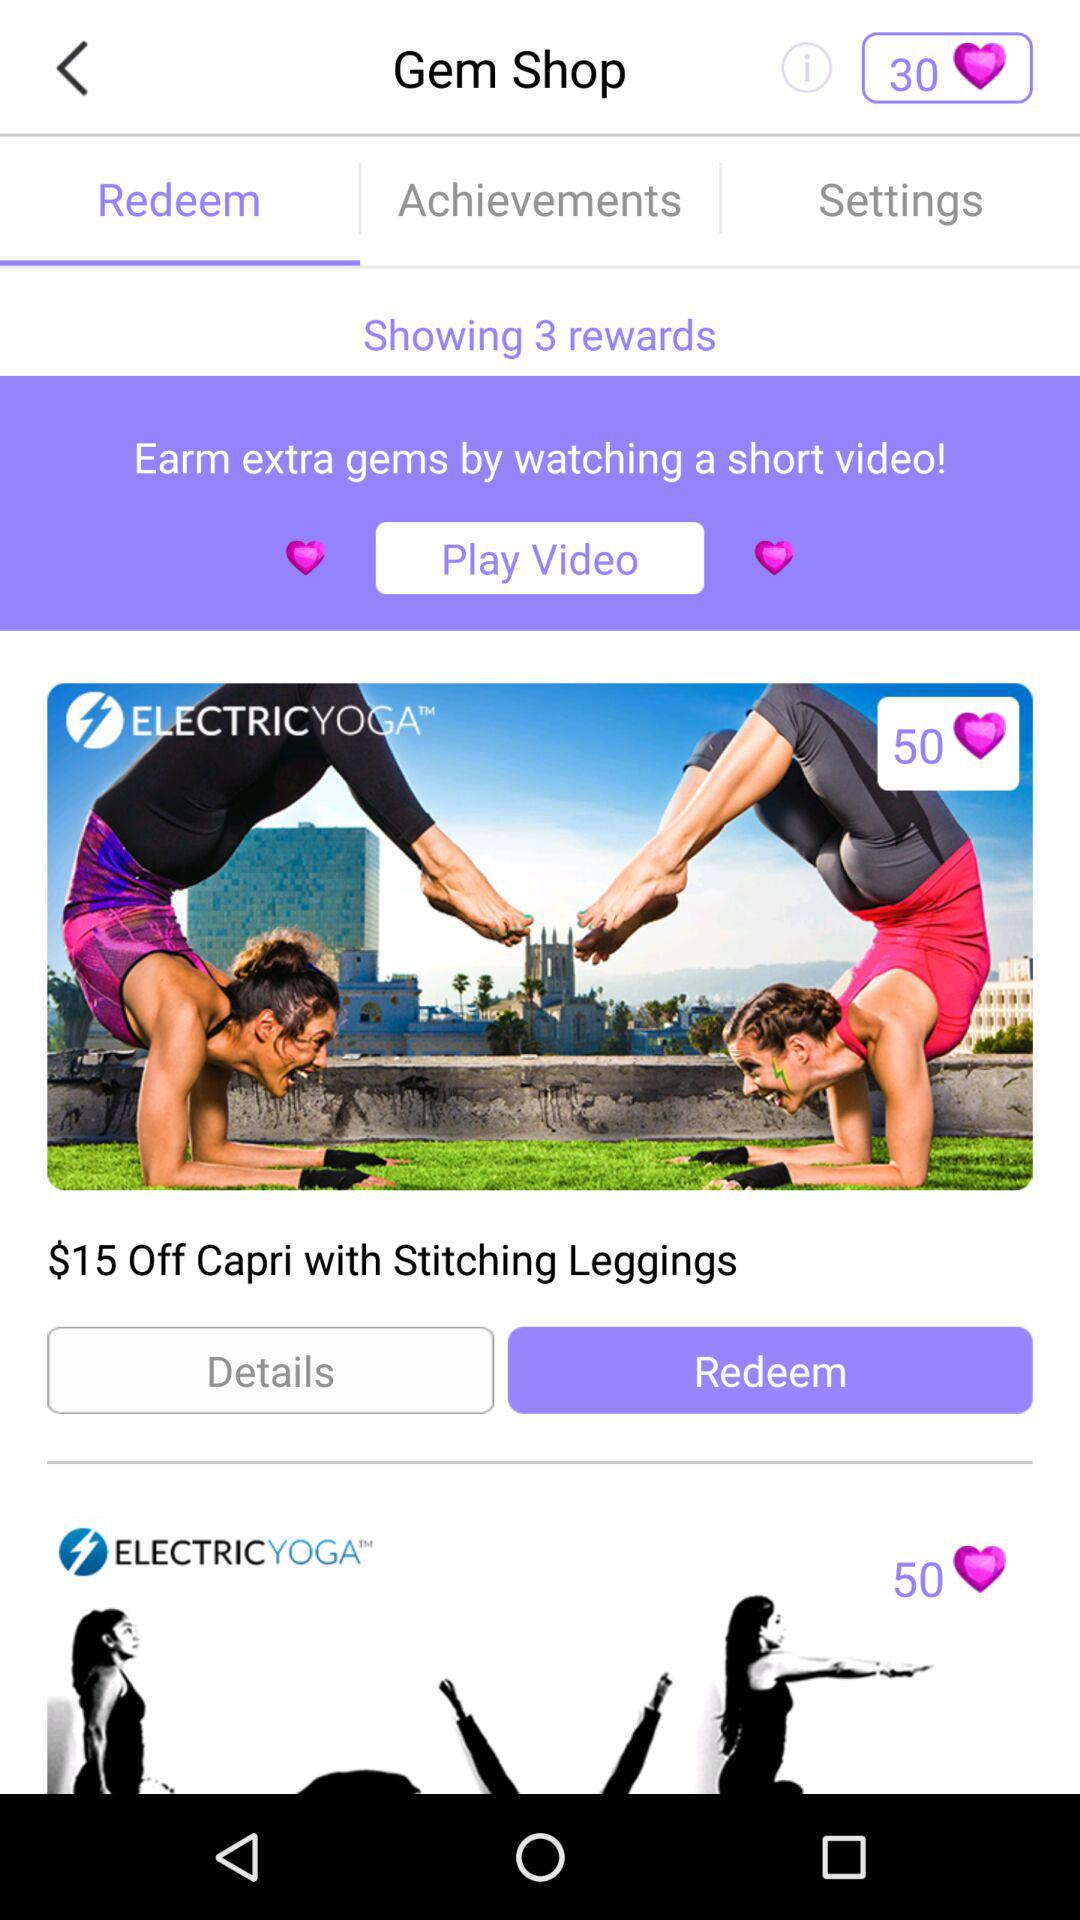Which tab has been selected? The tab "Redeem" has been selected. 